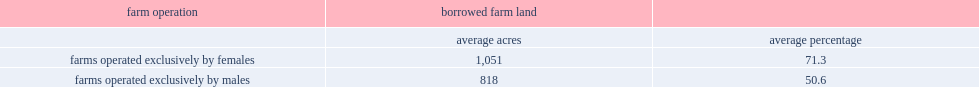For female-oprated farms, what percentage of farm operators' total farm land is borrowed? 71.3. What percent of farms operated exclusively by males is borrowed farmland? 50.6. Which gendar borrows more land on average, male or female? Farms operated exclusively by females. How many acres did female farm operators report renting or leasing land borrowed on average? 1051.0. How many acres did male farm operators report renting or leasing land borrowed on average? 818.0. 